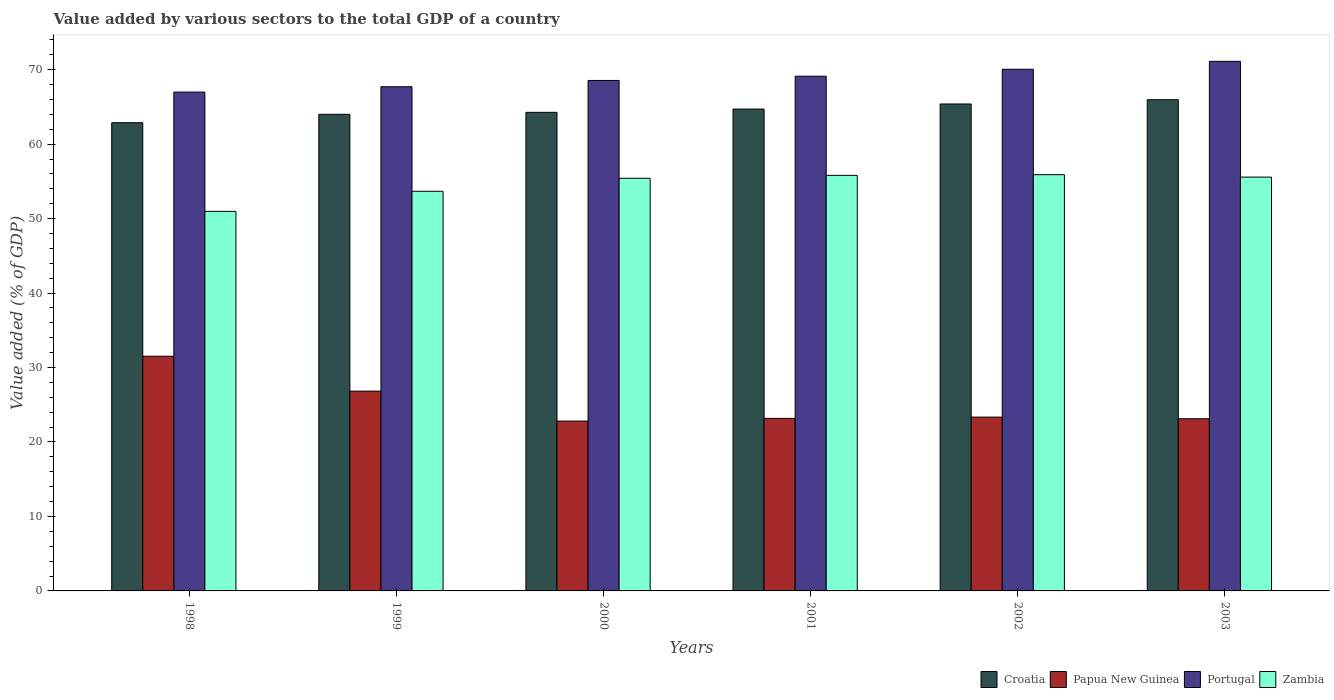How many different coloured bars are there?
Ensure brevity in your answer.  4. How many groups of bars are there?
Your answer should be compact. 6. What is the label of the 2nd group of bars from the left?
Your answer should be very brief. 1999. In how many cases, is the number of bars for a given year not equal to the number of legend labels?
Keep it short and to the point. 0. What is the value added by various sectors to the total GDP in Zambia in 1999?
Keep it short and to the point. 53.67. Across all years, what is the maximum value added by various sectors to the total GDP in Portugal?
Your answer should be very brief. 71.11. Across all years, what is the minimum value added by various sectors to the total GDP in Papua New Guinea?
Make the answer very short. 22.81. In which year was the value added by various sectors to the total GDP in Papua New Guinea minimum?
Keep it short and to the point. 2000. What is the total value added by various sectors to the total GDP in Portugal in the graph?
Make the answer very short. 413.53. What is the difference between the value added by various sectors to the total GDP in Croatia in 1998 and that in 2003?
Offer a terse response. -3.08. What is the difference between the value added by various sectors to the total GDP in Zambia in 2000 and the value added by various sectors to the total GDP in Croatia in 1998?
Your answer should be very brief. -7.46. What is the average value added by various sectors to the total GDP in Portugal per year?
Keep it short and to the point. 68.92. In the year 2000, what is the difference between the value added by various sectors to the total GDP in Portugal and value added by various sectors to the total GDP in Croatia?
Provide a short and direct response. 4.28. What is the ratio of the value added by various sectors to the total GDP in Portugal in 2001 to that in 2003?
Provide a succinct answer. 0.97. Is the value added by various sectors to the total GDP in Croatia in 1999 less than that in 2000?
Provide a succinct answer. Yes. Is the difference between the value added by various sectors to the total GDP in Portugal in 2001 and 2003 greater than the difference between the value added by various sectors to the total GDP in Croatia in 2001 and 2003?
Ensure brevity in your answer.  No. What is the difference between the highest and the second highest value added by various sectors to the total GDP in Portugal?
Keep it short and to the point. 1.06. What is the difference between the highest and the lowest value added by various sectors to the total GDP in Portugal?
Ensure brevity in your answer.  4.13. Is it the case that in every year, the sum of the value added by various sectors to the total GDP in Portugal and value added by various sectors to the total GDP in Croatia is greater than the sum of value added by various sectors to the total GDP in Zambia and value added by various sectors to the total GDP in Papua New Guinea?
Give a very brief answer. No. What does the 1st bar from the left in 2002 represents?
Your response must be concise. Croatia. What does the 3rd bar from the right in 1998 represents?
Make the answer very short. Papua New Guinea. How many bars are there?
Provide a short and direct response. 24. Are all the bars in the graph horizontal?
Your response must be concise. No. How many legend labels are there?
Ensure brevity in your answer.  4. How are the legend labels stacked?
Keep it short and to the point. Horizontal. What is the title of the graph?
Your response must be concise. Value added by various sectors to the total GDP of a country. What is the label or title of the X-axis?
Provide a succinct answer. Years. What is the label or title of the Y-axis?
Your answer should be compact. Value added (% of GDP). What is the Value added (% of GDP) in Croatia in 1998?
Keep it short and to the point. 62.88. What is the Value added (% of GDP) of Papua New Guinea in 1998?
Your answer should be compact. 31.51. What is the Value added (% of GDP) in Portugal in 1998?
Provide a succinct answer. 66.99. What is the Value added (% of GDP) of Zambia in 1998?
Give a very brief answer. 50.97. What is the Value added (% of GDP) in Croatia in 1999?
Give a very brief answer. 64. What is the Value added (% of GDP) of Papua New Guinea in 1999?
Give a very brief answer. 26.83. What is the Value added (% of GDP) of Portugal in 1999?
Keep it short and to the point. 67.7. What is the Value added (% of GDP) in Zambia in 1999?
Ensure brevity in your answer.  53.67. What is the Value added (% of GDP) of Croatia in 2000?
Provide a succinct answer. 64.27. What is the Value added (% of GDP) in Papua New Guinea in 2000?
Provide a short and direct response. 22.81. What is the Value added (% of GDP) of Portugal in 2000?
Your answer should be very brief. 68.55. What is the Value added (% of GDP) in Zambia in 2000?
Your answer should be compact. 55.41. What is the Value added (% of GDP) in Croatia in 2001?
Make the answer very short. 64.71. What is the Value added (% of GDP) in Papua New Guinea in 2001?
Your answer should be very brief. 23.17. What is the Value added (% of GDP) in Portugal in 2001?
Your response must be concise. 69.12. What is the Value added (% of GDP) in Zambia in 2001?
Your answer should be very brief. 55.8. What is the Value added (% of GDP) of Croatia in 2002?
Provide a succinct answer. 65.39. What is the Value added (% of GDP) in Papua New Guinea in 2002?
Your response must be concise. 23.34. What is the Value added (% of GDP) of Portugal in 2002?
Make the answer very short. 70.05. What is the Value added (% of GDP) of Zambia in 2002?
Provide a succinct answer. 55.89. What is the Value added (% of GDP) of Croatia in 2003?
Give a very brief answer. 65.96. What is the Value added (% of GDP) of Papua New Guinea in 2003?
Provide a succinct answer. 23.12. What is the Value added (% of GDP) of Portugal in 2003?
Make the answer very short. 71.11. What is the Value added (% of GDP) of Zambia in 2003?
Make the answer very short. 55.57. Across all years, what is the maximum Value added (% of GDP) in Croatia?
Provide a succinct answer. 65.96. Across all years, what is the maximum Value added (% of GDP) in Papua New Guinea?
Your response must be concise. 31.51. Across all years, what is the maximum Value added (% of GDP) of Portugal?
Your answer should be very brief. 71.11. Across all years, what is the maximum Value added (% of GDP) in Zambia?
Make the answer very short. 55.89. Across all years, what is the minimum Value added (% of GDP) in Croatia?
Provide a succinct answer. 62.88. Across all years, what is the minimum Value added (% of GDP) of Papua New Guinea?
Provide a succinct answer. 22.81. Across all years, what is the minimum Value added (% of GDP) in Portugal?
Offer a terse response. 66.99. Across all years, what is the minimum Value added (% of GDP) of Zambia?
Your answer should be compact. 50.97. What is the total Value added (% of GDP) of Croatia in the graph?
Provide a succinct answer. 387.2. What is the total Value added (% of GDP) in Papua New Guinea in the graph?
Ensure brevity in your answer.  150.78. What is the total Value added (% of GDP) of Portugal in the graph?
Make the answer very short. 413.53. What is the total Value added (% of GDP) in Zambia in the graph?
Keep it short and to the point. 327.31. What is the difference between the Value added (% of GDP) in Croatia in 1998 and that in 1999?
Ensure brevity in your answer.  -1.13. What is the difference between the Value added (% of GDP) of Papua New Guinea in 1998 and that in 1999?
Give a very brief answer. 4.68. What is the difference between the Value added (% of GDP) in Portugal in 1998 and that in 1999?
Offer a terse response. -0.72. What is the difference between the Value added (% of GDP) of Zambia in 1998 and that in 1999?
Provide a short and direct response. -2.7. What is the difference between the Value added (% of GDP) of Croatia in 1998 and that in 2000?
Offer a very short reply. -1.39. What is the difference between the Value added (% of GDP) in Papua New Guinea in 1998 and that in 2000?
Provide a succinct answer. 8.7. What is the difference between the Value added (% of GDP) in Portugal in 1998 and that in 2000?
Give a very brief answer. -1.56. What is the difference between the Value added (% of GDP) of Zambia in 1998 and that in 2000?
Your response must be concise. -4.45. What is the difference between the Value added (% of GDP) of Croatia in 1998 and that in 2001?
Make the answer very short. -1.83. What is the difference between the Value added (% of GDP) of Papua New Guinea in 1998 and that in 2001?
Ensure brevity in your answer.  8.34. What is the difference between the Value added (% of GDP) of Portugal in 1998 and that in 2001?
Provide a short and direct response. -2.13. What is the difference between the Value added (% of GDP) of Zambia in 1998 and that in 2001?
Make the answer very short. -4.84. What is the difference between the Value added (% of GDP) in Croatia in 1998 and that in 2002?
Offer a terse response. -2.51. What is the difference between the Value added (% of GDP) in Papua New Guinea in 1998 and that in 2002?
Provide a short and direct response. 8.17. What is the difference between the Value added (% of GDP) of Portugal in 1998 and that in 2002?
Your response must be concise. -3.06. What is the difference between the Value added (% of GDP) of Zambia in 1998 and that in 2002?
Provide a short and direct response. -4.93. What is the difference between the Value added (% of GDP) of Croatia in 1998 and that in 2003?
Give a very brief answer. -3.08. What is the difference between the Value added (% of GDP) in Papua New Guinea in 1998 and that in 2003?
Ensure brevity in your answer.  8.39. What is the difference between the Value added (% of GDP) of Portugal in 1998 and that in 2003?
Provide a succinct answer. -4.13. What is the difference between the Value added (% of GDP) in Zambia in 1998 and that in 2003?
Offer a terse response. -4.6. What is the difference between the Value added (% of GDP) of Croatia in 1999 and that in 2000?
Provide a short and direct response. -0.26. What is the difference between the Value added (% of GDP) in Papua New Guinea in 1999 and that in 2000?
Offer a very short reply. 4.02. What is the difference between the Value added (% of GDP) in Portugal in 1999 and that in 2000?
Keep it short and to the point. -0.85. What is the difference between the Value added (% of GDP) in Zambia in 1999 and that in 2000?
Keep it short and to the point. -1.75. What is the difference between the Value added (% of GDP) in Croatia in 1999 and that in 2001?
Offer a very short reply. -0.7. What is the difference between the Value added (% of GDP) of Papua New Guinea in 1999 and that in 2001?
Offer a terse response. 3.66. What is the difference between the Value added (% of GDP) in Portugal in 1999 and that in 2001?
Ensure brevity in your answer.  -1.41. What is the difference between the Value added (% of GDP) in Zambia in 1999 and that in 2001?
Make the answer very short. -2.13. What is the difference between the Value added (% of GDP) in Croatia in 1999 and that in 2002?
Provide a short and direct response. -1.39. What is the difference between the Value added (% of GDP) in Papua New Guinea in 1999 and that in 2002?
Keep it short and to the point. 3.49. What is the difference between the Value added (% of GDP) in Portugal in 1999 and that in 2002?
Provide a short and direct response. -2.35. What is the difference between the Value added (% of GDP) in Zambia in 1999 and that in 2002?
Your response must be concise. -2.23. What is the difference between the Value added (% of GDP) of Croatia in 1999 and that in 2003?
Provide a short and direct response. -1.96. What is the difference between the Value added (% of GDP) in Papua New Guinea in 1999 and that in 2003?
Ensure brevity in your answer.  3.71. What is the difference between the Value added (% of GDP) of Portugal in 1999 and that in 2003?
Provide a short and direct response. -3.41. What is the difference between the Value added (% of GDP) of Zambia in 1999 and that in 2003?
Your answer should be compact. -1.9. What is the difference between the Value added (% of GDP) of Croatia in 2000 and that in 2001?
Make the answer very short. -0.44. What is the difference between the Value added (% of GDP) of Papua New Guinea in 2000 and that in 2001?
Offer a very short reply. -0.36. What is the difference between the Value added (% of GDP) in Portugal in 2000 and that in 2001?
Your response must be concise. -0.57. What is the difference between the Value added (% of GDP) in Zambia in 2000 and that in 2001?
Provide a succinct answer. -0.39. What is the difference between the Value added (% of GDP) of Croatia in 2000 and that in 2002?
Your answer should be very brief. -1.12. What is the difference between the Value added (% of GDP) in Papua New Guinea in 2000 and that in 2002?
Your answer should be compact. -0.53. What is the difference between the Value added (% of GDP) of Portugal in 2000 and that in 2002?
Provide a succinct answer. -1.5. What is the difference between the Value added (% of GDP) in Zambia in 2000 and that in 2002?
Offer a terse response. -0.48. What is the difference between the Value added (% of GDP) in Croatia in 2000 and that in 2003?
Give a very brief answer. -1.69. What is the difference between the Value added (% of GDP) in Papua New Guinea in 2000 and that in 2003?
Your response must be concise. -0.31. What is the difference between the Value added (% of GDP) of Portugal in 2000 and that in 2003?
Make the answer very short. -2.56. What is the difference between the Value added (% of GDP) of Zambia in 2000 and that in 2003?
Keep it short and to the point. -0.16. What is the difference between the Value added (% of GDP) of Croatia in 2001 and that in 2002?
Make the answer very short. -0.68. What is the difference between the Value added (% of GDP) of Papua New Guinea in 2001 and that in 2002?
Offer a very short reply. -0.17. What is the difference between the Value added (% of GDP) in Portugal in 2001 and that in 2002?
Offer a very short reply. -0.93. What is the difference between the Value added (% of GDP) of Zambia in 2001 and that in 2002?
Your answer should be very brief. -0.09. What is the difference between the Value added (% of GDP) in Croatia in 2001 and that in 2003?
Offer a terse response. -1.25. What is the difference between the Value added (% of GDP) in Papua New Guinea in 2001 and that in 2003?
Ensure brevity in your answer.  0.05. What is the difference between the Value added (% of GDP) of Portugal in 2001 and that in 2003?
Provide a succinct answer. -1.99. What is the difference between the Value added (% of GDP) in Zambia in 2001 and that in 2003?
Offer a terse response. 0.23. What is the difference between the Value added (% of GDP) of Croatia in 2002 and that in 2003?
Offer a very short reply. -0.57. What is the difference between the Value added (% of GDP) in Papua New Guinea in 2002 and that in 2003?
Provide a succinct answer. 0.22. What is the difference between the Value added (% of GDP) in Portugal in 2002 and that in 2003?
Provide a short and direct response. -1.06. What is the difference between the Value added (% of GDP) of Zambia in 2002 and that in 2003?
Your response must be concise. 0.32. What is the difference between the Value added (% of GDP) of Croatia in 1998 and the Value added (% of GDP) of Papua New Guinea in 1999?
Your answer should be compact. 36.05. What is the difference between the Value added (% of GDP) in Croatia in 1998 and the Value added (% of GDP) in Portugal in 1999?
Provide a short and direct response. -4.83. What is the difference between the Value added (% of GDP) in Croatia in 1998 and the Value added (% of GDP) in Zambia in 1999?
Your answer should be compact. 9.21. What is the difference between the Value added (% of GDP) in Papua New Guinea in 1998 and the Value added (% of GDP) in Portugal in 1999?
Provide a short and direct response. -36.19. What is the difference between the Value added (% of GDP) in Papua New Guinea in 1998 and the Value added (% of GDP) in Zambia in 1999?
Ensure brevity in your answer.  -22.16. What is the difference between the Value added (% of GDP) in Portugal in 1998 and the Value added (% of GDP) in Zambia in 1999?
Provide a succinct answer. 13.32. What is the difference between the Value added (% of GDP) in Croatia in 1998 and the Value added (% of GDP) in Papua New Guinea in 2000?
Offer a terse response. 40.07. What is the difference between the Value added (% of GDP) of Croatia in 1998 and the Value added (% of GDP) of Portugal in 2000?
Offer a terse response. -5.68. What is the difference between the Value added (% of GDP) of Croatia in 1998 and the Value added (% of GDP) of Zambia in 2000?
Offer a very short reply. 7.46. What is the difference between the Value added (% of GDP) of Papua New Guinea in 1998 and the Value added (% of GDP) of Portugal in 2000?
Provide a short and direct response. -37.04. What is the difference between the Value added (% of GDP) of Papua New Guinea in 1998 and the Value added (% of GDP) of Zambia in 2000?
Your response must be concise. -23.9. What is the difference between the Value added (% of GDP) in Portugal in 1998 and the Value added (% of GDP) in Zambia in 2000?
Ensure brevity in your answer.  11.57. What is the difference between the Value added (% of GDP) in Croatia in 1998 and the Value added (% of GDP) in Papua New Guinea in 2001?
Offer a terse response. 39.71. What is the difference between the Value added (% of GDP) of Croatia in 1998 and the Value added (% of GDP) of Portugal in 2001?
Your answer should be compact. -6.24. What is the difference between the Value added (% of GDP) in Croatia in 1998 and the Value added (% of GDP) in Zambia in 2001?
Provide a succinct answer. 7.07. What is the difference between the Value added (% of GDP) in Papua New Guinea in 1998 and the Value added (% of GDP) in Portugal in 2001?
Your answer should be compact. -37.61. What is the difference between the Value added (% of GDP) in Papua New Guinea in 1998 and the Value added (% of GDP) in Zambia in 2001?
Provide a succinct answer. -24.29. What is the difference between the Value added (% of GDP) in Portugal in 1998 and the Value added (% of GDP) in Zambia in 2001?
Offer a very short reply. 11.19. What is the difference between the Value added (% of GDP) in Croatia in 1998 and the Value added (% of GDP) in Papua New Guinea in 2002?
Your answer should be very brief. 39.53. What is the difference between the Value added (% of GDP) of Croatia in 1998 and the Value added (% of GDP) of Portugal in 2002?
Your response must be concise. -7.18. What is the difference between the Value added (% of GDP) of Croatia in 1998 and the Value added (% of GDP) of Zambia in 2002?
Your response must be concise. 6.98. What is the difference between the Value added (% of GDP) of Papua New Guinea in 1998 and the Value added (% of GDP) of Portugal in 2002?
Make the answer very short. -38.54. What is the difference between the Value added (% of GDP) in Papua New Guinea in 1998 and the Value added (% of GDP) in Zambia in 2002?
Ensure brevity in your answer.  -24.38. What is the difference between the Value added (% of GDP) of Portugal in 1998 and the Value added (% of GDP) of Zambia in 2002?
Make the answer very short. 11.09. What is the difference between the Value added (% of GDP) of Croatia in 1998 and the Value added (% of GDP) of Papua New Guinea in 2003?
Make the answer very short. 39.75. What is the difference between the Value added (% of GDP) in Croatia in 1998 and the Value added (% of GDP) in Portugal in 2003?
Ensure brevity in your answer.  -8.24. What is the difference between the Value added (% of GDP) of Croatia in 1998 and the Value added (% of GDP) of Zambia in 2003?
Provide a short and direct response. 7.3. What is the difference between the Value added (% of GDP) in Papua New Guinea in 1998 and the Value added (% of GDP) in Portugal in 2003?
Ensure brevity in your answer.  -39.6. What is the difference between the Value added (% of GDP) of Papua New Guinea in 1998 and the Value added (% of GDP) of Zambia in 2003?
Provide a succinct answer. -24.06. What is the difference between the Value added (% of GDP) in Portugal in 1998 and the Value added (% of GDP) in Zambia in 2003?
Your answer should be compact. 11.42. What is the difference between the Value added (% of GDP) in Croatia in 1999 and the Value added (% of GDP) in Papua New Guinea in 2000?
Make the answer very short. 41.19. What is the difference between the Value added (% of GDP) in Croatia in 1999 and the Value added (% of GDP) in Portugal in 2000?
Your answer should be very brief. -4.55. What is the difference between the Value added (% of GDP) of Croatia in 1999 and the Value added (% of GDP) of Zambia in 2000?
Provide a succinct answer. 8.59. What is the difference between the Value added (% of GDP) of Papua New Guinea in 1999 and the Value added (% of GDP) of Portugal in 2000?
Your response must be concise. -41.72. What is the difference between the Value added (% of GDP) in Papua New Guinea in 1999 and the Value added (% of GDP) in Zambia in 2000?
Give a very brief answer. -28.58. What is the difference between the Value added (% of GDP) in Portugal in 1999 and the Value added (% of GDP) in Zambia in 2000?
Make the answer very short. 12.29. What is the difference between the Value added (% of GDP) of Croatia in 1999 and the Value added (% of GDP) of Papua New Guinea in 2001?
Your response must be concise. 40.84. What is the difference between the Value added (% of GDP) in Croatia in 1999 and the Value added (% of GDP) in Portugal in 2001?
Provide a short and direct response. -5.12. What is the difference between the Value added (% of GDP) in Croatia in 1999 and the Value added (% of GDP) in Zambia in 2001?
Your answer should be very brief. 8.2. What is the difference between the Value added (% of GDP) in Papua New Guinea in 1999 and the Value added (% of GDP) in Portugal in 2001?
Provide a succinct answer. -42.29. What is the difference between the Value added (% of GDP) in Papua New Guinea in 1999 and the Value added (% of GDP) in Zambia in 2001?
Offer a very short reply. -28.97. What is the difference between the Value added (% of GDP) in Portugal in 1999 and the Value added (% of GDP) in Zambia in 2001?
Offer a terse response. 11.9. What is the difference between the Value added (% of GDP) of Croatia in 1999 and the Value added (% of GDP) of Papua New Guinea in 2002?
Your answer should be compact. 40.66. What is the difference between the Value added (% of GDP) in Croatia in 1999 and the Value added (% of GDP) in Portugal in 2002?
Your answer should be very brief. -6.05. What is the difference between the Value added (% of GDP) of Croatia in 1999 and the Value added (% of GDP) of Zambia in 2002?
Make the answer very short. 8.11. What is the difference between the Value added (% of GDP) in Papua New Guinea in 1999 and the Value added (% of GDP) in Portugal in 2002?
Your response must be concise. -43.22. What is the difference between the Value added (% of GDP) of Papua New Guinea in 1999 and the Value added (% of GDP) of Zambia in 2002?
Provide a succinct answer. -29.07. What is the difference between the Value added (% of GDP) in Portugal in 1999 and the Value added (% of GDP) in Zambia in 2002?
Your answer should be compact. 11.81. What is the difference between the Value added (% of GDP) in Croatia in 1999 and the Value added (% of GDP) in Papua New Guinea in 2003?
Provide a succinct answer. 40.88. What is the difference between the Value added (% of GDP) in Croatia in 1999 and the Value added (% of GDP) in Portugal in 2003?
Make the answer very short. -7.11. What is the difference between the Value added (% of GDP) in Croatia in 1999 and the Value added (% of GDP) in Zambia in 2003?
Your answer should be compact. 8.43. What is the difference between the Value added (% of GDP) in Papua New Guinea in 1999 and the Value added (% of GDP) in Portugal in 2003?
Make the answer very short. -44.28. What is the difference between the Value added (% of GDP) of Papua New Guinea in 1999 and the Value added (% of GDP) of Zambia in 2003?
Keep it short and to the point. -28.74. What is the difference between the Value added (% of GDP) of Portugal in 1999 and the Value added (% of GDP) of Zambia in 2003?
Give a very brief answer. 12.13. What is the difference between the Value added (% of GDP) in Croatia in 2000 and the Value added (% of GDP) in Papua New Guinea in 2001?
Your answer should be compact. 41.1. What is the difference between the Value added (% of GDP) in Croatia in 2000 and the Value added (% of GDP) in Portugal in 2001?
Your response must be concise. -4.85. What is the difference between the Value added (% of GDP) in Croatia in 2000 and the Value added (% of GDP) in Zambia in 2001?
Your answer should be compact. 8.46. What is the difference between the Value added (% of GDP) in Papua New Guinea in 2000 and the Value added (% of GDP) in Portugal in 2001?
Provide a succinct answer. -46.31. What is the difference between the Value added (% of GDP) of Papua New Guinea in 2000 and the Value added (% of GDP) of Zambia in 2001?
Provide a succinct answer. -32.99. What is the difference between the Value added (% of GDP) of Portugal in 2000 and the Value added (% of GDP) of Zambia in 2001?
Make the answer very short. 12.75. What is the difference between the Value added (% of GDP) of Croatia in 2000 and the Value added (% of GDP) of Papua New Guinea in 2002?
Provide a succinct answer. 40.93. What is the difference between the Value added (% of GDP) in Croatia in 2000 and the Value added (% of GDP) in Portugal in 2002?
Ensure brevity in your answer.  -5.78. What is the difference between the Value added (% of GDP) of Croatia in 2000 and the Value added (% of GDP) of Zambia in 2002?
Your answer should be very brief. 8.37. What is the difference between the Value added (% of GDP) in Papua New Guinea in 2000 and the Value added (% of GDP) in Portugal in 2002?
Offer a very short reply. -47.24. What is the difference between the Value added (% of GDP) of Papua New Guinea in 2000 and the Value added (% of GDP) of Zambia in 2002?
Your response must be concise. -33.09. What is the difference between the Value added (% of GDP) in Portugal in 2000 and the Value added (% of GDP) in Zambia in 2002?
Provide a short and direct response. 12.66. What is the difference between the Value added (% of GDP) in Croatia in 2000 and the Value added (% of GDP) in Papua New Guinea in 2003?
Offer a terse response. 41.15. What is the difference between the Value added (% of GDP) in Croatia in 2000 and the Value added (% of GDP) in Portugal in 2003?
Your answer should be compact. -6.85. What is the difference between the Value added (% of GDP) in Croatia in 2000 and the Value added (% of GDP) in Zambia in 2003?
Offer a very short reply. 8.7. What is the difference between the Value added (% of GDP) of Papua New Guinea in 2000 and the Value added (% of GDP) of Portugal in 2003?
Offer a terse response. -48.3. What is the difference between the Value added (% of GDP) in Papua New Guinea in 2000 and the Value added (% of GDP) in Zambia in 2003?
Give a very brief answer. -32.76. What is the difference between the Value added (% of GDP) of Portugal in 2000 and the Value added (% of GDP) of Zambia in 2003?
Offer a very short reply. 12.98. What is the difference between the Value added (% of GDP) of Croatia in 2001 and the Value added (% of GDP) of Papua New Guinea in 2002?
Provide a succinct answer. 41.36. What is the difference between the Value added (% of GDP) of Croatia in 2001 and the Value added (% of GDP) of Portugal in 2002?
Your response must be concise. -5.35. What is the difference between the Value added (% of GDP) in Croatia in 2001 and the Value added (% of GDP) in Zambia in 2002?
Keep it short and to the point. 8.81. What is the difference between the Value added (% of GDP) in Papua New Guinea in 2001 and the Value added (% of GDP) in Portugal in 2002?
Keep it short and to the point. -46.88. What is the difference between the Value added (% of GDP) of Papua New Guinea in 2001 and the Value added (% of GDP) of Zambia in 2002?
Provide a succinct answer. -32.73. What is the difference between the Value added (% of GDP) of Portugal in 2001 and the Value added (% of GDP) of Zambia in 2002?
Keep it short and to the point. 13.22. What is the difference between the Value added (% of GDP) in Croatia in 2001 and the Value added (% of GDP) in Papua New Guinea in 2003?
Your answer should be compact. 41.59. What is the difference between the Value added (% of GDP) of Croatia in 2001 and the Value added (% of GDP) of Portugal in 2003?
Ensure brevity in your answer.  -6.41. What is the difference between the Value added (% of GDP) of Croatia in 2001 and the Value added (% of GDP) of Zambia in 2003?
Make the answer very short. 9.13. What is the difference between the Value added (% of GDP) of Papua New Guinea in 2001 and the Value added (% of GDP) of Portugal in 2003?
Give a very brief answer. -47.95. What is the difference between the Value added (% of GDP) of Papua New Guinea in 2001 and the Value added (% of GDP) of Zambia in 2003?
Make the answer very short. -32.4. What is the difference between the Value added (% of GDP) in Portugal in 2001 and the Value added (% of GDP) in Zambia in 2003?
Your answer should be compact. 13.55. What is the difference between the Value added (% of GDP) in Croatia in 2002 and the Value added (% of GDP) in Papua New Guinea in 2003?
Provide a short and direct response. 42.27. What is the difference between the Value added (% of GDP) in Croatia in 2002 and the Value added (% of GDP) in Portugal in 2003?
Give a very brief answer. -5.72. What is the difference between the Value added (% of GDP) of Croatia in 2002 and the Value added (% of GDP) of Zambia in 2003?
Give a very brief answer. 9.82. What is the difference between the Value added (% of GDP) of Papua New Guinea in 2002 and the Value added (% of GDP) of Portugal in 2003?
Give a very brief answer. -47.77. What is the difference between the Value added (% of GDP) of Papua New Guinea in 2002 and the Value added (% of GDP) of Zambia in 2003?
Your response must be concise. -32.23. What is the difference between the Value added (% of GDP) of Portugal in 2002 and the Value added (% of GDP) of Zambia in 2003?
Your answer should be compact. 14.48. What is the average Value added (% of GDP) in Croatia per year?
Make the answer very short. 64.53. What is the average Value added (% of GDP) of Papua New Guinea per year?
Offer a terse response. 25.13. What is the average Value added (% of GDP) of Portugal per year?
Your response must be concise. 68.92. What is the average Value added (% of GDP) of Zambia per year?
Your response must be concise. 54.55. In the year 1998, what is the difference between the Value added (% of GDP) in Croatia and Value added (% of GDP) in Papua New Guinea?
Provide a succinct answer. 31.36. In the year 1998, what is the difference between the Value added (% of GDP) of Croatia and Value added (% of GDP) of Portugal?
Offer a very short reply. -4.11. In the year 1998, what is the difference between the Value added (% of GDP) of Croatia and Value added (% of GDP) of Zambia?
Provide a short and direct response. 11.91. In the year 1998, what is the difference between the Value added (% of GDP) in Papua New Guinea and Value added (% of GDP) in Portugal?
Your answer should be compact. -35.48. In the year 1998, what is the difference between the Value added (% of GDP) in Papua New Guinea and Value added (% of GDP) in Zambia?
Give a very brief answer. -19.46. In the year 1998, what is the difference between the Value added (% of GDP) of Portugal and Value added (% of GDP) of Zambia?
Offer a very short reply. 16.02. In the year 1999, what is the difference between the Value added (% of GDP) of Croatia and Value added (% of GDP) of Papua New Guinea?
Give a very brief answer. 37.17. In the year 1999, what is the difference between the Value added (% of GDP) of Croatia and Value added (% of GDP) of Portugal?
Your answer should be compact. -3.7. In the year 1999, what is the difference between the Value added (% of GDP) in Croatia and Value added (% of GDP) in Zambia?
Keep it short and to the point. 10.34. In the year 1999, what is the difference between the Value added (% of GDP) of Papua New Guinea and Value added (% of GDP) of Portugal?
Keep it short and to the point. -40.88. In the year 1999, what is the difference between the Value added (% of GDP) of Papua New Guinea and Value added (% of GDP) of Zambia?
Give a very brief answer. -26.84. In the year 1999, what is the difference between the Value added (% of GDP) of Portugal and Value added (% of GDP) of Zambia?
Offer a terse response. 14.04. In the year 2000, what is the difference between the Value added (% of GDP) in Croatia and Value added (% of GDP) in Papua New Guinea?
Ensure brevity in your answer.  41.46. In the year 2000, what is the difference between the Value added (% of GDP) in Croatia and Value added (% of GDP) in Portugal?
Ensure brevity in your answer.  -4.28. In the year 2000, what is the difference between the Value added (% of GDP) of Croatia and Value added (% of GDP) of Zambia?
Offer a very short reply. 8.85. In the year 2000, what is the difference between the Value added (% of GDP) of Papua New Guinea and Value added (% of GDP) of Portugal?
Offer a very short reply. -45.74. In the year 2000, what is the difference between the Value added (% of GDP) of Papua New Guinea and Value added (% of GDP) of Zambia?
Your answer should be compact. -32.6. In the year 2000, what is the difference between the Value added (% of GDP) in Portugal and Value added (% of GDP) in Zambia?
Give a very brief answer. 13.14. In the year 2001, what is the difference between the Value added (% of GDP) of Croatia and Value added (% of GDP) of Papua New Guinea?
Your response must be concise. 41.54. In the year 2001, what is the difference between the Value added (% of GDP) in Croatia and Value added (% of GDP) in Portugal?
Your answer should be very brief. -4.41. In the year 2001, what is the difference between the Value added (% of GDP) of Croatia and Value added (% of GDP) of Zambia?
Your answer should be very brief. 8.9. In the year 2001, what is the difference between the Value added (% of GDP) of Papua New Guinea and Value added (% of GDP) of Portugal?
Give a very brief answer. -45.95. In the year 2001, what is the difference between the Value added (% of GDP) in Papua New Guinea and Value added (% of GDP) in Zambia?
Your response must be concise. -32.64. In the year 2001, what is the difference between the Value added (% of GDP) in Portugal and Value added (% of GDP) in Zambia?
Keep it short and to the point. 13.32. In the year 2002, what is the difference between the Value added (% of GDP) in Croatia and Value added (% of GDP) in Papua New Guinea?
Your answer should be compact. 42.05. In the year 2002, what is the difference between the Value added (% of GDP) in Croatia and Value added (% of GDP) in Portugal?
Your answer should be very brief. -4.66. In the year 2002, what is the difference between the Value added (% of GDP) in Croatia and Value added (% of GDP) in Zambia?
Make the answer very short. 9.49. In the year 2002, what is the difference between the Value added (% of GDP) in Papua New Guinea and Value added (% of GDP) in Portugal?
Your answer should be very brief. -46.71. In the year 2002, what is the difference between the Value added (% of GDP) in Papua New Guinea and Value added (% of GDP) in Zambia?
Keep it short and to the point. -32.55. In the year 2002, what is the difference between the Value added (% of GDP) in Portugal and Value added (% of GDP) in Zambia?
Make the answer very short. 14.16. In the year 2003, what is the difference between the Value added (% of GDP) in Croatia and Value added (% of GDP) in Papua New Guinea?
Your response must be concise. 42.84. In the year 2003, what is the difference between the Value added (% of GDP) of Croatia and Value added (% of GDP) of Portugal?
Make the answer very short. -5.15. In the year 2003, what is the difference between the Value added (% of GDP) in Croatia and Value added (% of GDP) in Zambia?
Your answer should be compact. 10.39. In the year 2003, what is the difference between the Value added (% of GDP) of Papua New Guinea and Value added (% of GDP) of Portugal?
Give a very brief answer. -47.99. In the year 2003, what is the difference between the Value added (% of GDP) of Papua New Guinea and Value added (% of GDP) of Zambia?
Offer a very short reply. -32.45. In the year 2003, what is the difference between the Value added (% of GDP) of Portugal and Value added (% of GDP) of Zambia?
Provide a short and direct response. 15.54. What is the ratio of the Value added (% of GDP) of Croatia in 1998 to that in 1999?
Your response must be concise. 0.98. What is the ratio of the Value added (% of GDP) in Papua New Guinea in 1998 to that in 1999?
Provide a short and direct response. 1.17. What is the ratio of the Value added (% of GDP) of Portugal in 1998 to that in 1999?
Offer a terse response. 0.99. What is the ratio of the Value added (% of GDP) of Zambia in 1998 to that in 1999?
Your answer should be compact. 0.95. What is the ratio of the Value added (% of GDP) of Croatia in 1998 to that in 2000?
Your answer should be compact. 0.98. What is the ratio of the Value added (% of GDP) in Papua New Guinea in 1998 to that in 2000?
Provide a short and direct response. 1.38. What is the ratio of the Value added (% of GDP) in Portugal in 1998 to that in 2000?
Make the answer very short. 0.98. What is the ratio of the Value added (% of GDP) of Zambia in 1998 to that in 2000?
Make the answer very short. 0.92. What is the ratio of the Value added (% of GDP) in Croatia in 1998 to that in 2001?
Give a very brief answer. 0.97. What is the ratio of the Value added (% of GDP) in Papua New Guinea in 1998 to that in 2001?
Give a very brief answer. 1.36. What is the ratio of the Value added (% of GDP) in Portugal in 1998 to that in 2001?
Your answer should be compact. 0.97. What is the ratio of the Value added (% of GDP) of Zambia in 1998 to that in 2001?
Ensure brevity in your answer.  0.91. What is the ratio of the Value added (% of GDP) in Croatia in 1998 to that in 2002?
Keep it short and to the point. 0.96. What is the ratio of the Value added (% of GDP) of Papua New Guinea in 1998 to that in 2002?
Offer a terse response. 1.35. What is the ratio of the Value added (% of GDP) in Portugal in 1998 to that in 2002?
Provide a short and direct response. 0.96. What is the ratio of the Value added (% of GDP) of Zambia in 1998 to that in 2002?
Provide a short and direct response. 0.91. What is the ratio of the Value added (% of GDP) of Croatia in 1998 to that in 2003?
Ensure brevity in your answer.  0.95. What is the ratio of the Value added (% of GDP) in Papua New Guinea in 1998 to that in 2003?
Provide a succinct answer. 1.36. What is the ratio of the Value added (% of GDP) of Portugal in 1998 to that in 2003?
Provide a succinct answer. 0.94. What is the ratio of the Value added (% of GDP) in Zambia in 1998 to that in 2003?
Give a very brief answer. 0.92. What is the ratio of the Value added (% of GDP) in Croatia in 1999 to that in 2000?
Provide a short and direct response. 1. What is the ratio of the Value added (% of GDP) in Papua New Guinea in 1999 to that in 2000?
Provide a succinct answer. 1.18. What is the ratio of the Value added (% of GDP) of Portugal in 1999 to that in 2000?
Give a very brief answer. 0.99. What is the ratio of the Value added (% of GDP) of Zambia in 1999 to that in 2000?
Offer a very short reply. 0.97. What is the ratio of the Value added (% of GDP) in Papua New Guinea in 1999 to that in 2001?
Make the answer very short. 1.16. What is the ratio of the Value added (% of GDP) in Portugal in 1999 to that in 2001?
Make the answer very short. 0.98. What is the ratio of the Value added (% of GDP) in Zambia in 1999 to that in 2001?
Provide a short and direct response. 0.96. What is the ratio of the Value added (% of GDP) of Croatia in 1999 to that in 2002?
Ensure brevity in your answer.  0.98. What is the ratio of the Value added (% of GDP) in Papua New Guinea in 1999 to that in 2002?
Make the answer very short. 1.15. What is the ratio of the Value added (% of GDP) of Portugal in 1999 to that in 2002?
Your response must be concise. 0.97. What is the ratio of the Value added (% of GDP) of Zambia in 1999 to that in 2002?
Offer a very short reply. 0.96. What is the ratio of the Value added (% of GDP) in Croatia in 1999 to that in 2003?
Provide a short and direct response. 0.97. What is the ratio of the Value added (% of GDP) in Papua New Guinea in 1999 to that in 2003?
Offer a very short reply. 1.16. What is the ratio of the Value added (% of GDP) of Portugal in 1999 to that in 2003?
Your answer should be compact. 0.95. What is the ratio of the Value added (% of GDP) of Zambia in 1999 to that in 2003?
Offer a terse response. 0.97. What is the ratio of the Value added (% of GDP) in Papua New Guinea in 2000 to that in 2001?
Give a very brief answer. 0.98. What is the ratio of the Value added (% of GDP) of Zambia in 2000 to that in 2001?
Give a very brief answer. 0.99. What is the ratio of the Value added (% of GDP) in Croatia in 2000 to that in 2002?
Give a very brief answer. 0.98. What is the ratio of the Value added (% of GDP) of Papua New Guinea in 2000 to that in 2002?
Your response must be concise. 0.98. What is the ratio of the Value added (% of GDP) in Portugal in 2000 to that in 2002?
Your answer should be very brief. 0.98. What is the ratio of the Value added (% of GDP) of Zambia in 2000 to that in 2002?
Your answer should be very brief. 0.99. What is the ratio of the Value added (% of GDP) of Croatia in 2000 to that in 2003?
Your response must be concise. 0.97. What is the ratio of the Value added (% of GDP) in Papua New Guinea in 2000 to that in 2003?
Your response must be concise. 0.99. What is the ratio of the Value added (% of GDP) in Portugal in 2000 to that in 2003?
Your answer should be very brief. 0.96. What is the ratio of the Value added (% of GDP) of Zambia in 2000 to that in 2003?
Ensure brevity in your answer.  1. What is the ratio of the Value added (% of GDP) of Papua New Guinea in 2001 to that in 2002?
Offer a terse response. 0.99. What is the ratio of the Value added (% of GDP) of Portugal in 2001 to that in 2002?
Provide a succinct answer. 0.99. What is the ratio of the Value added (% of GDP) of Zambia in 2001 to that in 2002?
Your answer should be very brief. 1. What is the ratio of the Value added (% of GDP) in Croatia in 2001 to that in 2003?
Give a very brief answer. 0.98. What is the ratio of the Value added (% of GDP) of Zambia in 2001 to that in 2003?
Provide a succinct answer. 1. What is the ratio of the Value added (% of GDP) in Croatia in 2002 to that in 2003?
Make the answer very short. 0.99. What is the ratio of the Value added (% of GDP) in Papua New Guinea in 2002 to that in 2003?
Your answer should be compact. 1.01. What is the ratio of the Value added (% of GDP) in Portugal in 2002 to that in 2003?
Your answer should be compact. 0.99. What is the ratio of the Value added (% of GDP) of Zambia in 2002 to that in 2003?
Offer a very short reply. 1.01. What is the difference between the highest and the second highest Value added (% of GDP) of Croatia?
Offer a very short reply. 0.57. What is the difference between the highest and the second highest Value added (% of GDP) of Papua New Guinea?
Your answer should be very brief. 4.68. What is the difference between the highest and the second highest Value added (% of GDP) of Portugal?
Your response must be concise. 1.06. What is the difference between the highest and the second highest Value added (% of GDP) of Zambia?
Ensure brevity in your answer.  0.09. What is the difference between the highest and the lowest Value added (% of GDP) in Croatia?
Make the answer very short. 3.08. What is the difference between the highest and the lowest Value added (% of GDP) of Papua New Guinea?
Give a very brief answer. 8.7. What is the difference between the highest and the lowest Value added (% of GDP) in Portugal?
Offer a very short reply. 4.13. What is the difference between the highest and the lowest Value added (% of GDP) of Zambia?
Ensure brevity in your answer.  4.93. 